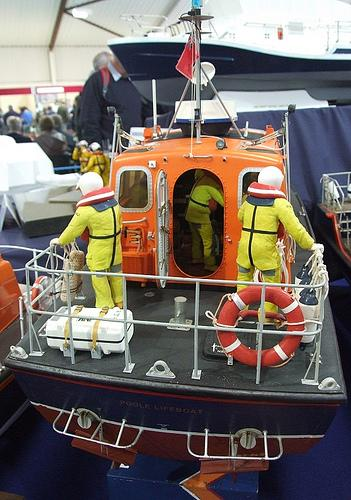Who are the men wearing yellow? workers 